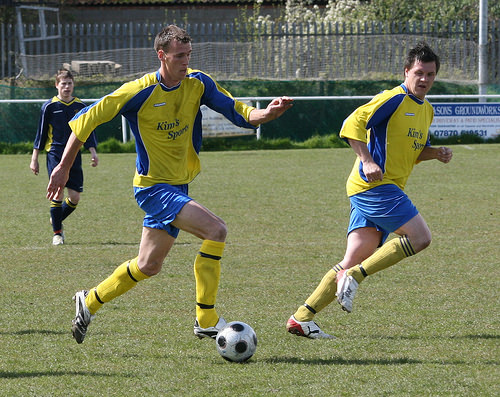<image>
Is the man on the man? No. The man is not positioned on the man. They may be near each other, but the man is not supported by or resting on top of the man. 